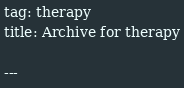Convert code to text. <code><loc_0><loc_0><loc_500><loc_500><_HTML_>tag: therapy
title: Archive for therapy

---
</code> 